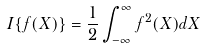<formula> <loc_0><loc_0><loc_500><loc_500>I \{ f ( X ) \} = \frac { 1 } { 2 } \int _ { - \infty } ^ { \infty } f ^ { 2 } ( X ) d X</formula> 